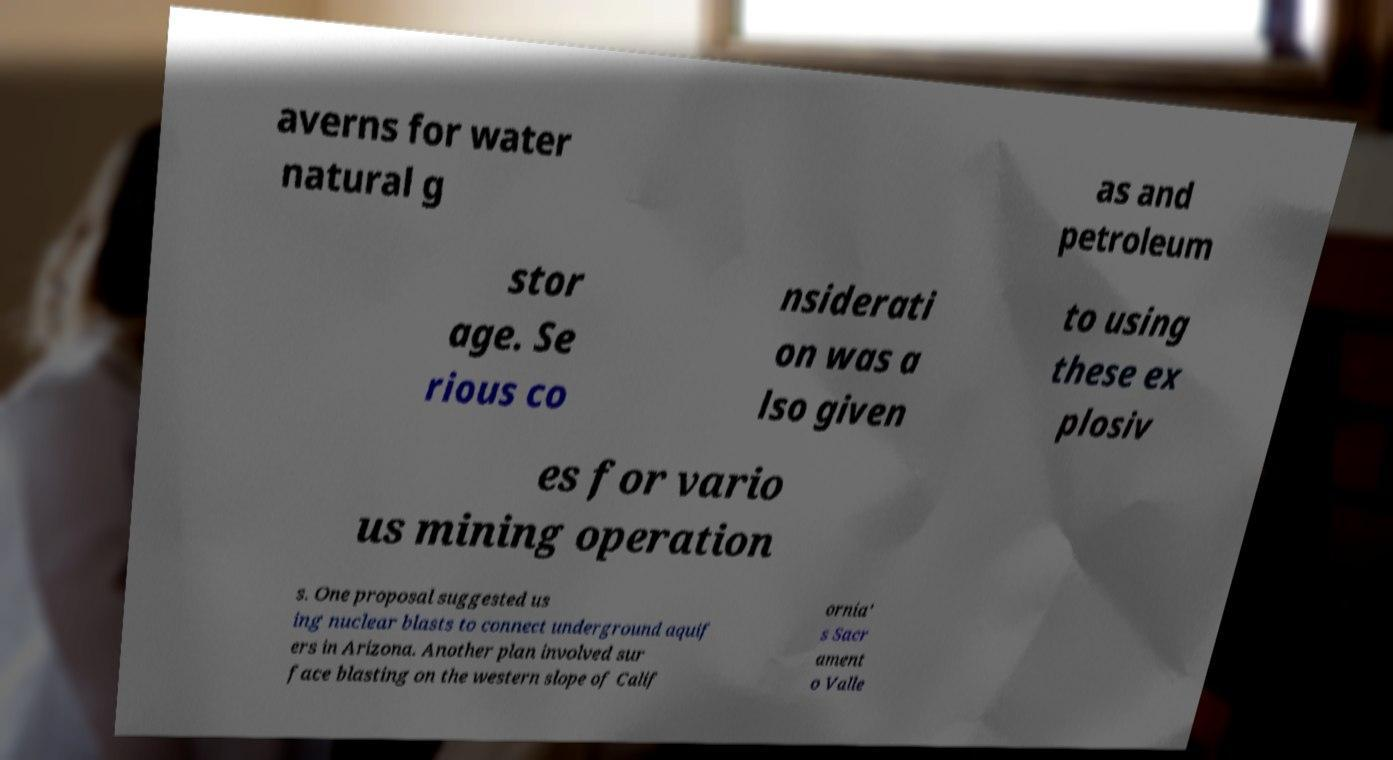Could you assist in decoding the text presented in this image and type it out clearly? averns for water natural g as and petroleum stor age. Se rious co nsiderati on was a lso given to using these ex plosiv es for vario us mining operation s. One proposal suggested us ing nuclear blasts to connect underground aquif ers in Arizona. Another plan involved sur face blasting on the western slope of Calif ornia' s Sacr ament o Valle 